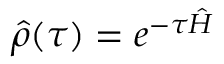<formula> <loc_0><loc_0><loc_500><loc_500>\hat { \rho } ( \tau ) = e ^ { - \tau \hat { H } }</formula> 